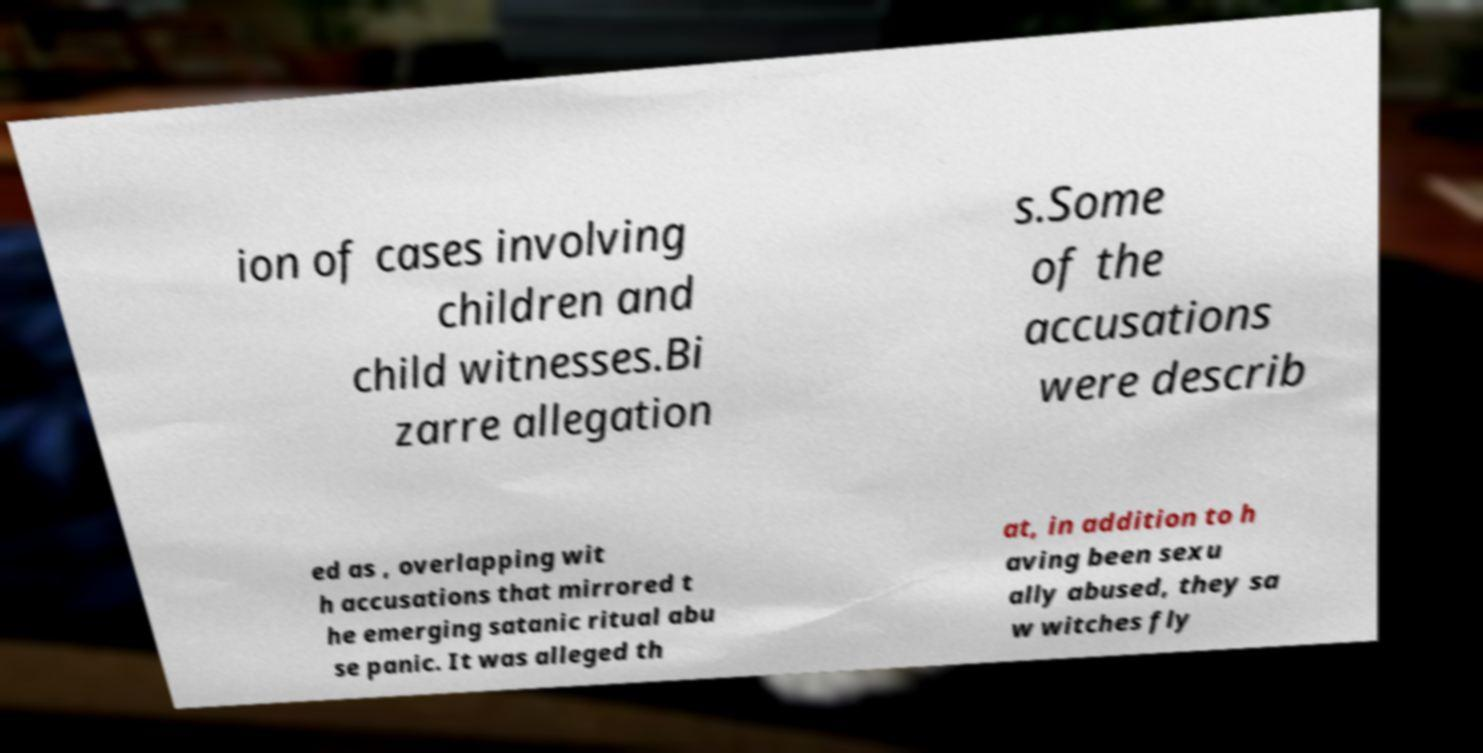Please identify and transcribe the text found in this image. ion of cases involving children and child witnesses.Bi zarre allegation s.Some of the accusations were describ ed as , overlapping wit h accusations that mirrored t he emerging satanic ritual abu se panic. It was alleged th at, in addition to h aving been sexu ally abused, they sa w witches fly 